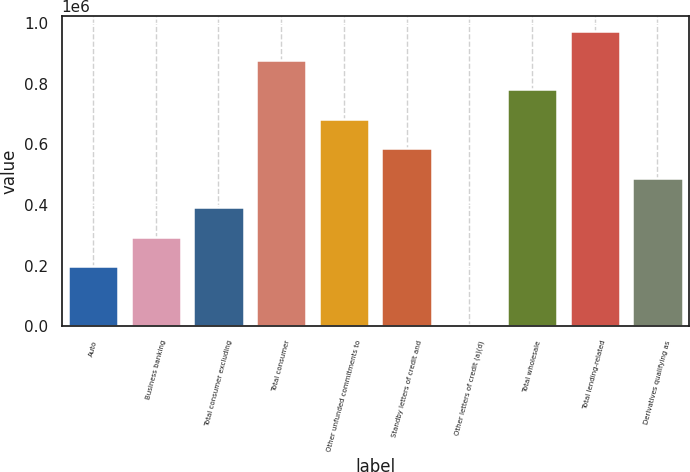Convert chart to OTSL. <chart><loc_0><loc_0><loc_500><loc_500><bar_chart><fcel>Auto<fcel>Business banking<fcel>Total consumer excluding<fcel>Total consumer<fcel>Other unfunded commitments to<fcel>Standby letters of credit and<fcel>Other letters of credit (a)(d)<fcel>Total wholesale<fcel>Total lending-related<fcel>Derivatives qualifying as<nl><fcel>199441<fcel>296469<fcel>393496<fcel>878634<fcel>684579<fcel>587552<fcel>5386<fcel>781607<fcel>975662<fcel>490524<nl></chart> 